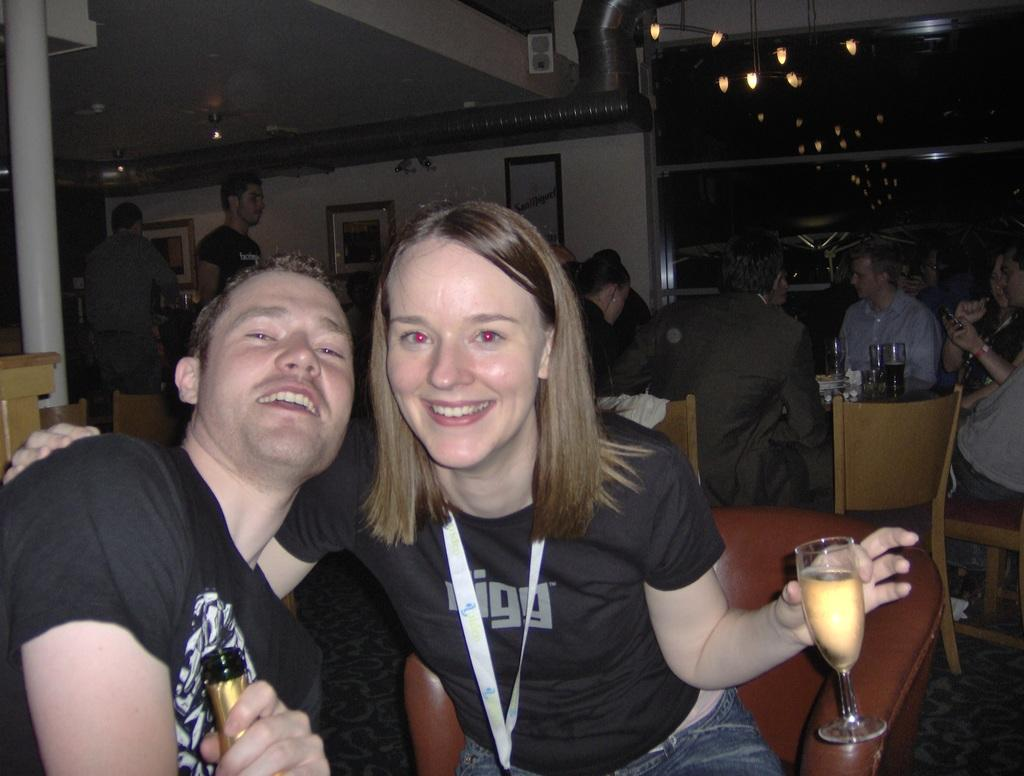<image>
Offer a succinct explanation of the picture presented. A man and woman with a Digg shirt pose for a photo at a busy bar. 